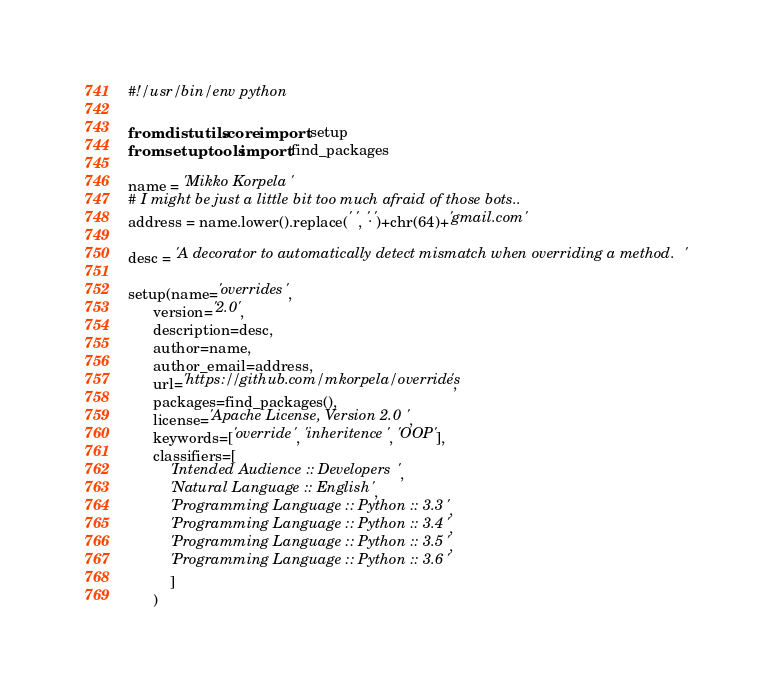Convert code to text. <code><loc_0><loc_0><loc_500><loc_500><_Python_>#!/usr/bin/env python

from distutils.core import setup
from setuptools import find_packages

name = 'Mikko Korpela'
# I might be just a little bit too much afraid of those bots..
address = name.lower().replace(' ', '.')+chr(64)+'gmail.com'

desc = 'A decorator to automatically detect mismatch when overriding a method.'

setup(name='overrides',
      version='2.0',
      description=desc,
      author=name,
      author_email=address,
      url='https://github.com/mkorpela/overrides',
      packages=find_packages(),
      license='Apache License, Version 2.0',
      keywords=['override', 'inheritence', 'OOP'],
      classifiers=[
          'Intended Audience :: Developers',
          'Natural Language :: English',
          'Programming Language :: Python :: 3.3',
          'Programming Language :: Python :: 3.4',
          'Programming Language :: Python :: 3.5',
          'Programming Language :: Python :: 3.6'
          ]
      )
</code> 